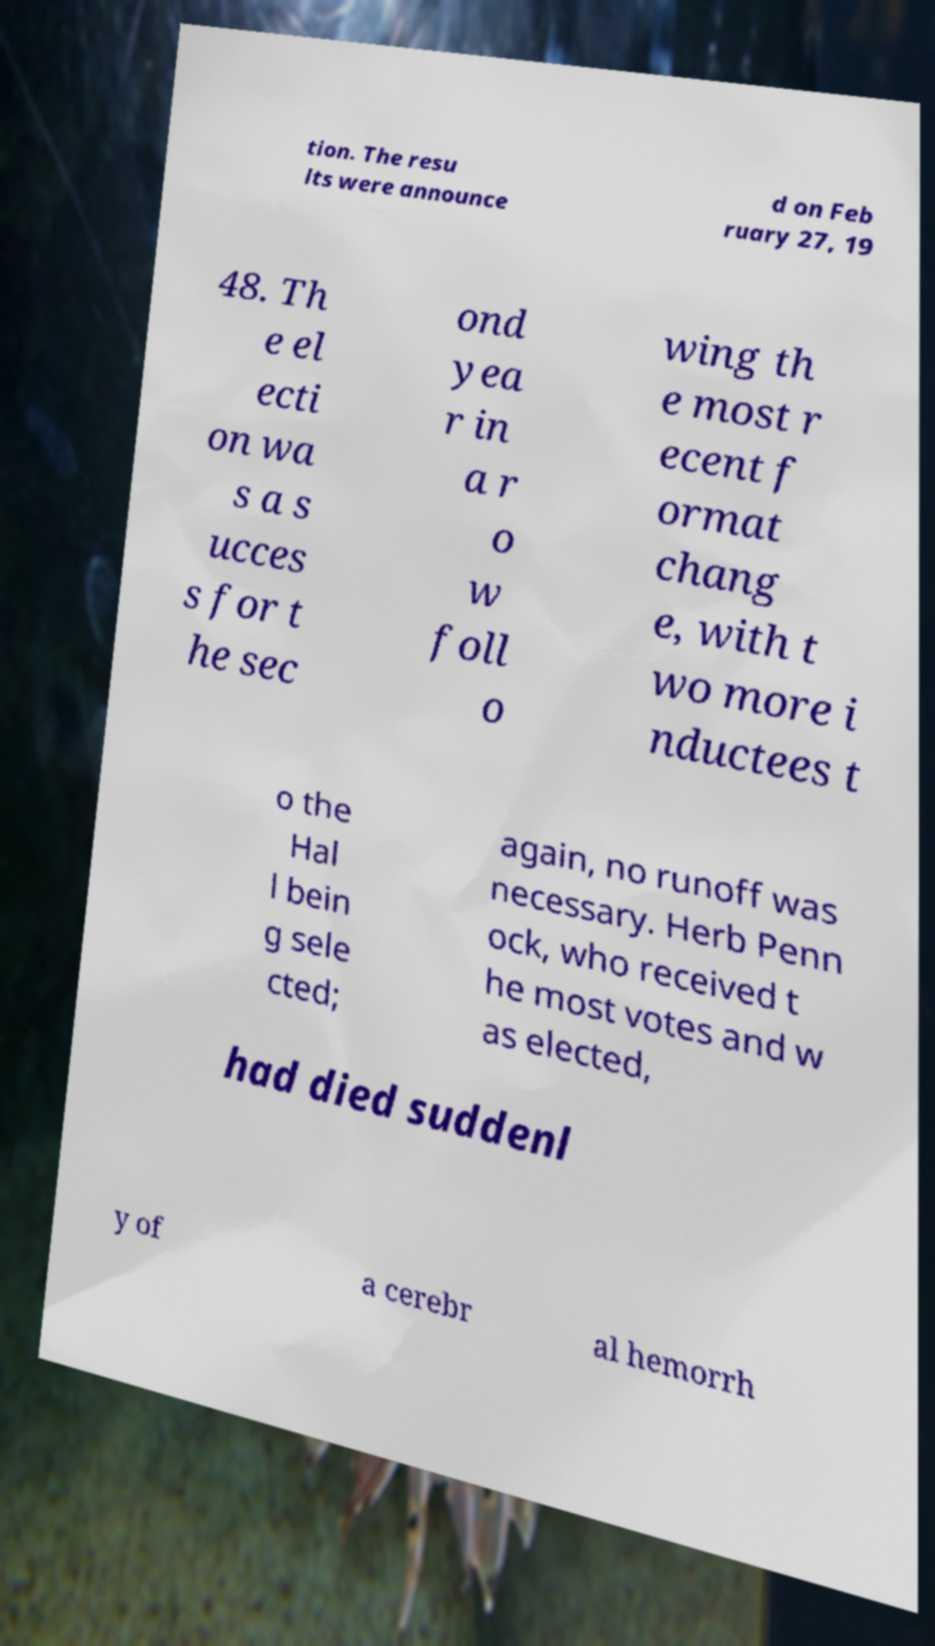Can you read and provide the text displayed in the image?This photo seems to have some interesting text. Can you extract and type it out for me? tion. The resu lts were announce d on Feb ruary 27, 19 48. Th e el ecti on wa s a s ucces s for t he sec ond yea r in a r o w foll o wing th e most r ecent f ormat chang e, with t wo more i nductees t o the Hal l bein g sele cted; again, no runoff was necessary. Herb Penn ock, who received t he most votes and w as elected, had died suddenl y of a cerebr al hemorrh 